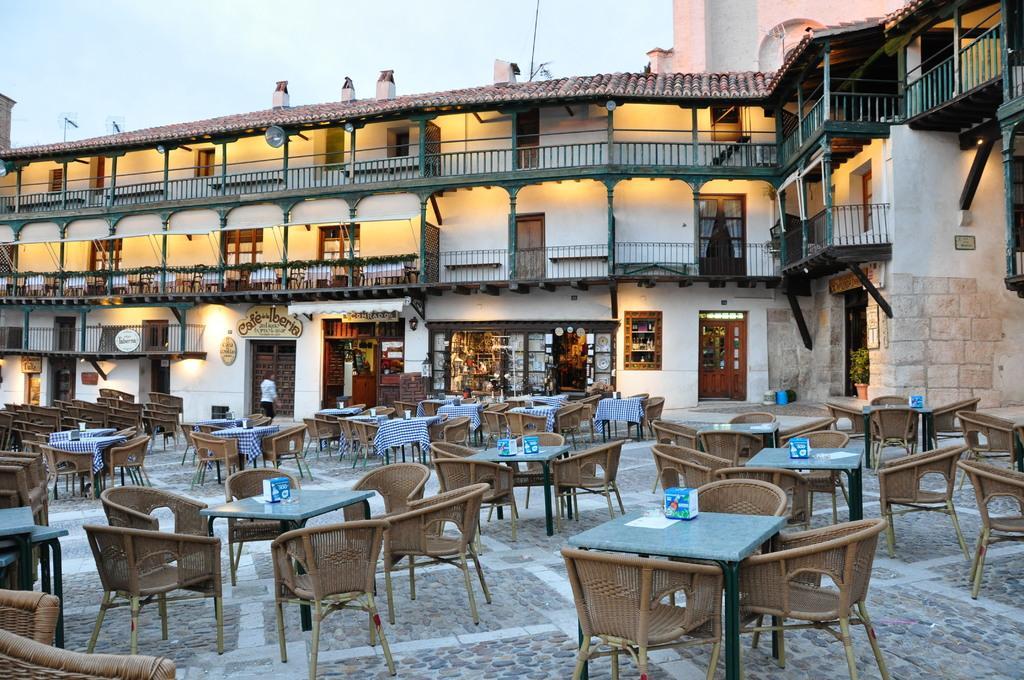Please provide a concise description of this image. In the center of the image there are chairs and tables. In the background of the image there is a building. There are windows, doors. There is a store. At the top of the image there is sky. At the bottom of the image there is floor. 